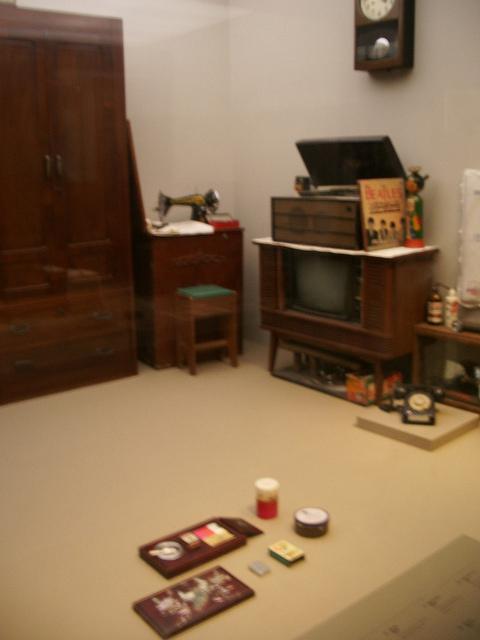How many bowls are in the picture?
Give a very brief answer. 1. 